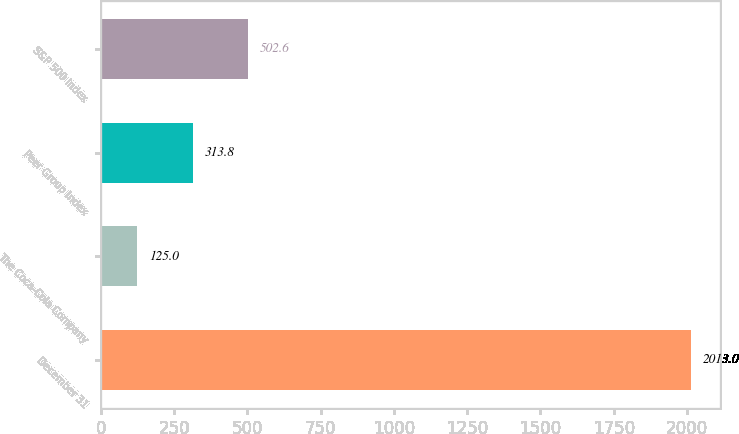Convert chart. <chart><loc_0><loc_0><loc_500><loc_500><bar_chart><fcel>December 31<fcel>The Coca-Cola Company<fcel>Peer Group Index<fcel>S&P 500 Index<nl><fcel>2013<fcel>125<fcel>313.8<fcel>502.6<nl></chart> 